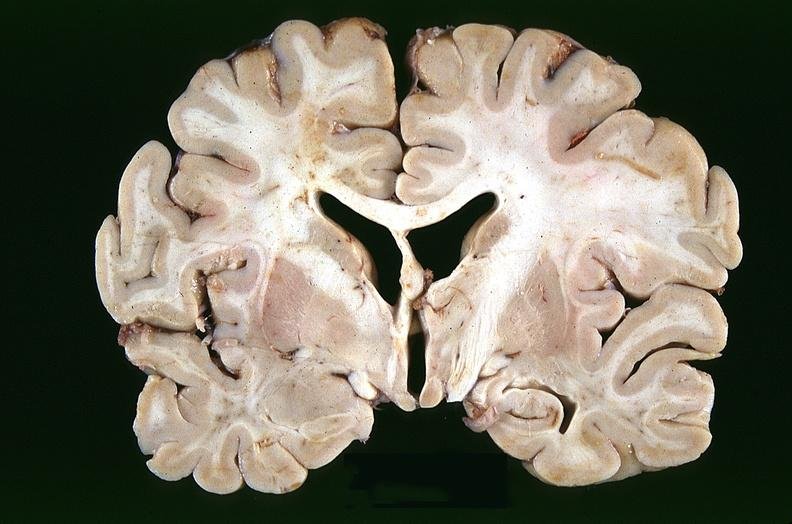does this image show brain, infarcts, hypotension?
Answer the question using a single word or phrase. Yes 